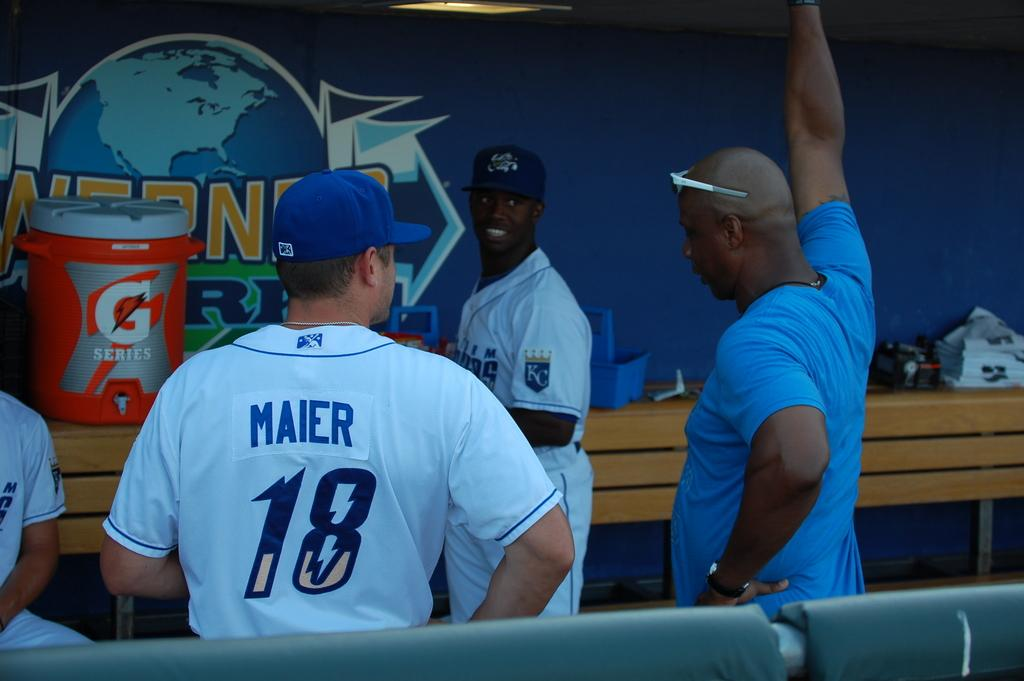<image>
Summarize the visual content of the image. a player in a dugout with the number 18 on 